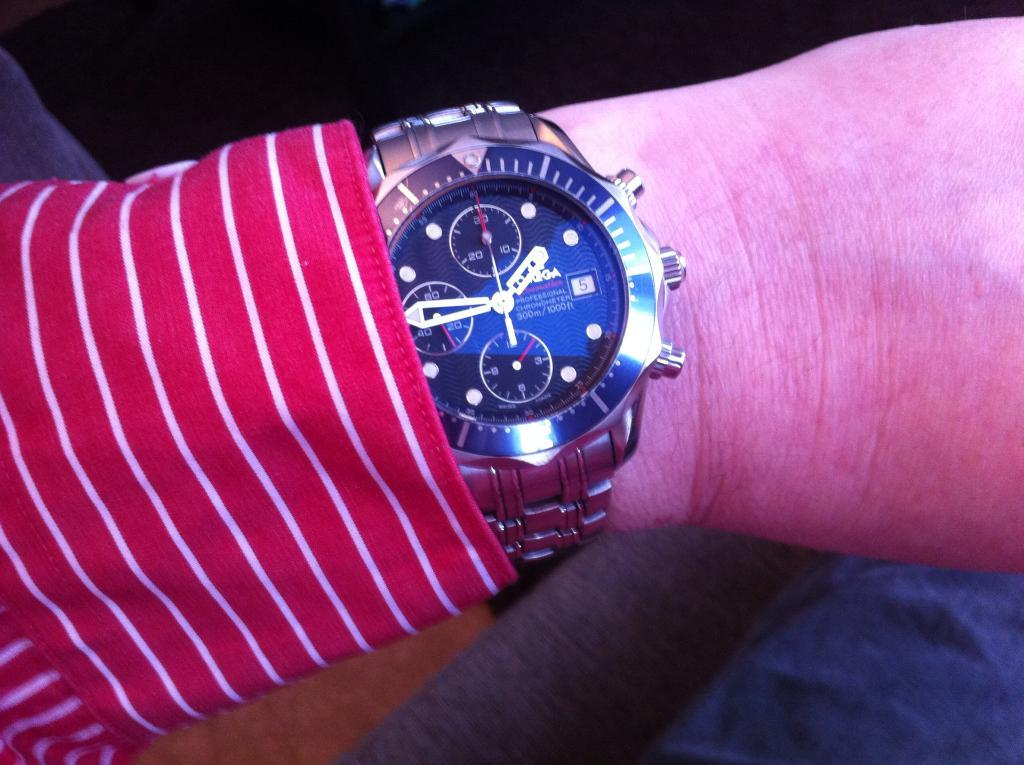<image>
Relay a brief, clear account of the picture shown. A person in a red shirt shows a watch that is waterproof down to 300 meters. 